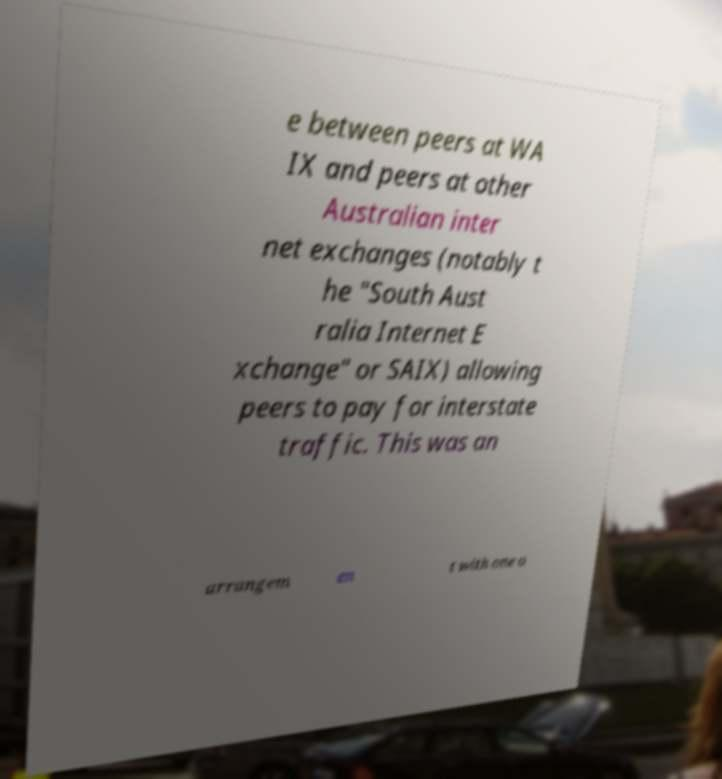I need the written content from this picture converted into text. Can you do that? e between peers at WA IX and peers at other Australian inter net exchanges (notably t he "South Aust ralia Internet E xchange" or SAIX) allowing peers to pay for interstate traffic. This was an arrangem en t with one o 